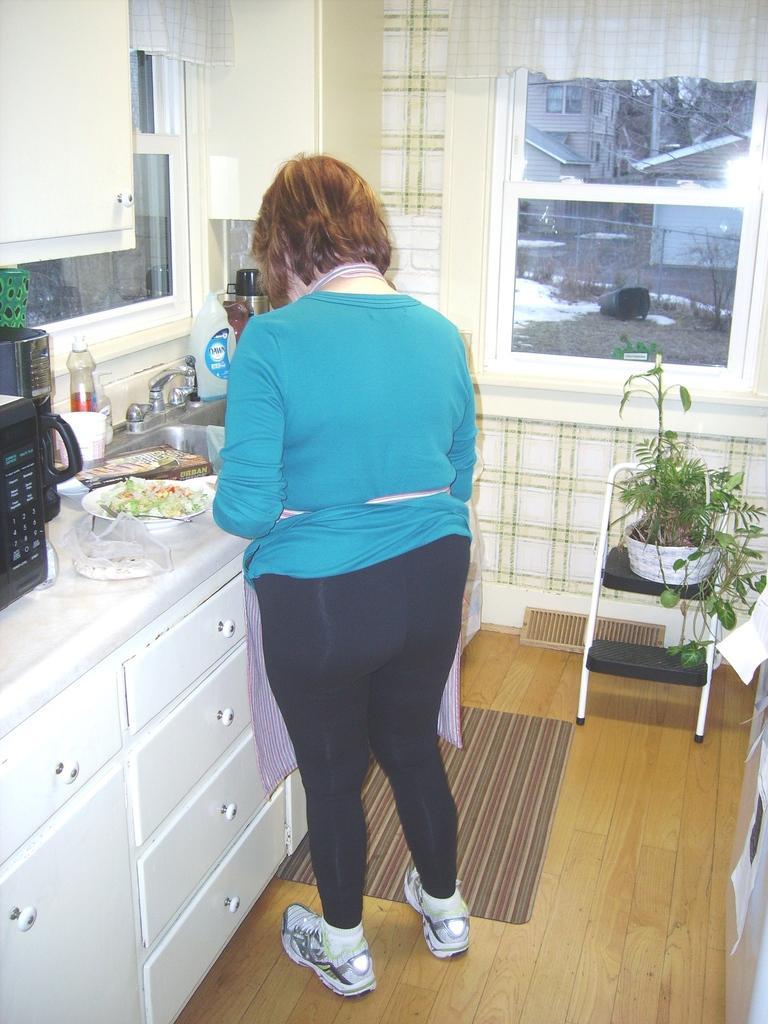Describe this image in one or two sentences. Here we can see a woman standing in the center and she is working in a kitchen. There is a clay pot on a chair which is on the right side 